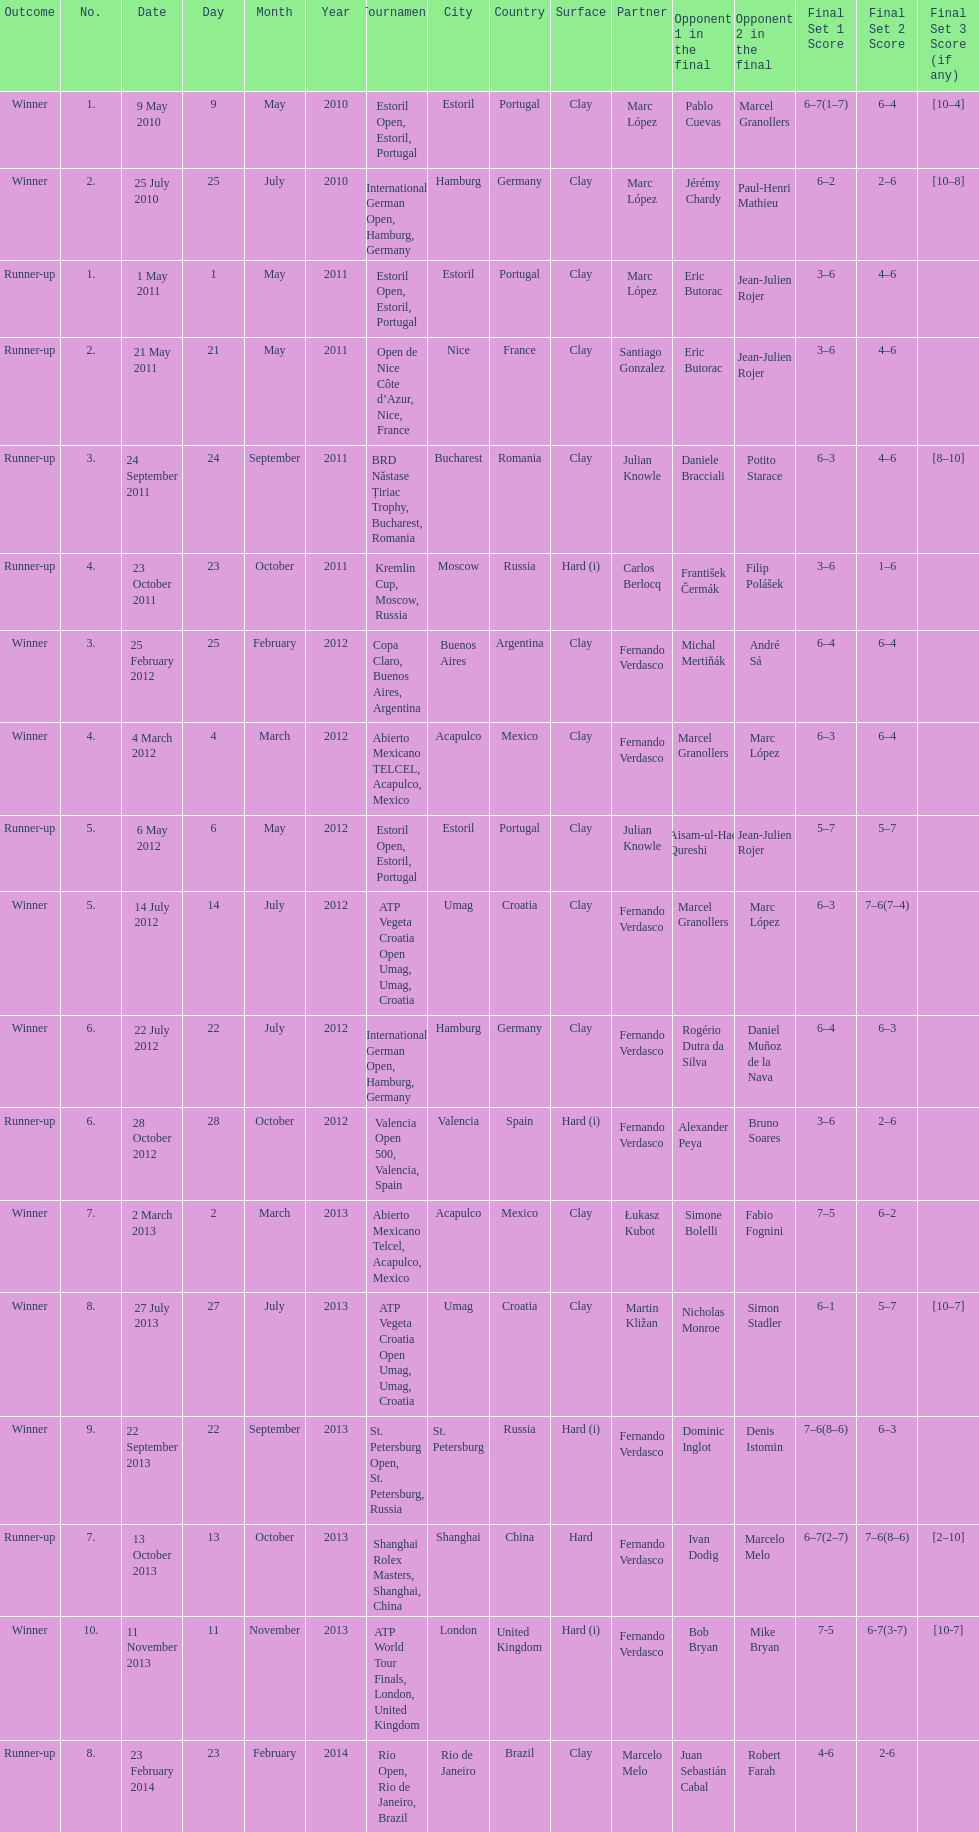How many runner-ups at most are listed? 8. 